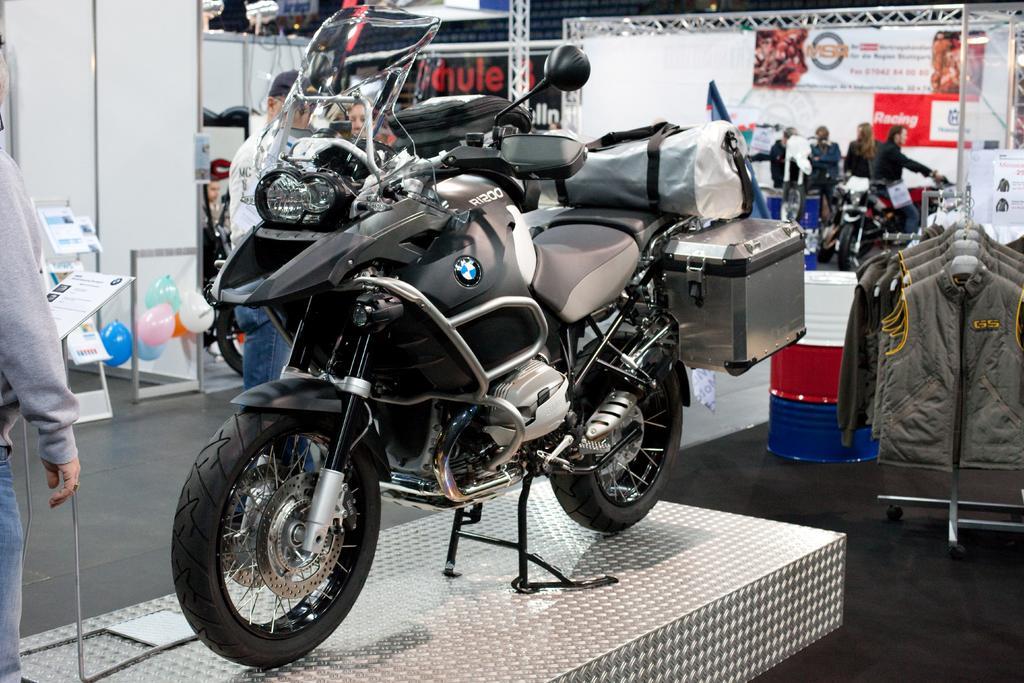Describe this image in one or two sentences. In the middle of the picture, we see a bike in grey and black color. On the right side, we see the jackets are hanged to the hangers. Beside that, we see a drum in white, red and blue color. On the left side, we see a man is standing. In front of him, we see the boards in white color with some text written on it. Beside that, we see the balloons in blue, green, pink, orange and white color. In the background, we see the banners in white and black color with some text written on it. We even see the people are standing in the background. 